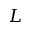Convert formula to latex. <formula><loc_0><loc_0><loc_500><loc_500>L</formula> 